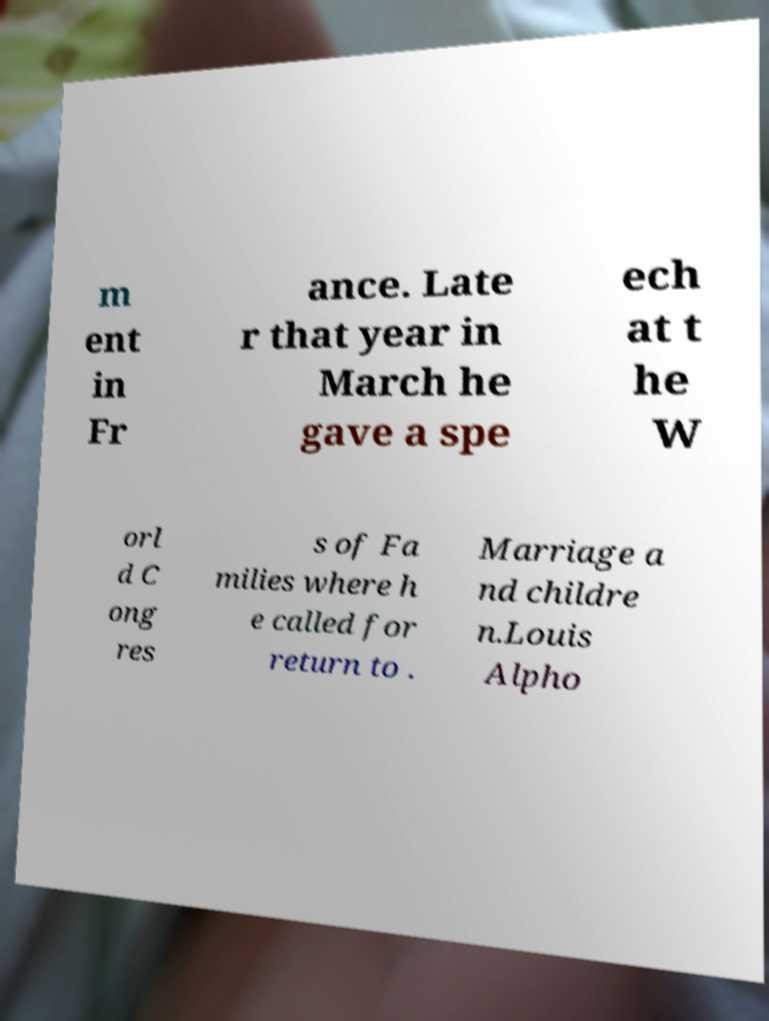Could you extract and type out the text from this image? m ent in Fr ance. Late r that year in March he gave a spe ech at t he W orl d C ong res s of Fa milies where h e called for return to . Marriage a nd childre n.Louis Alpho 